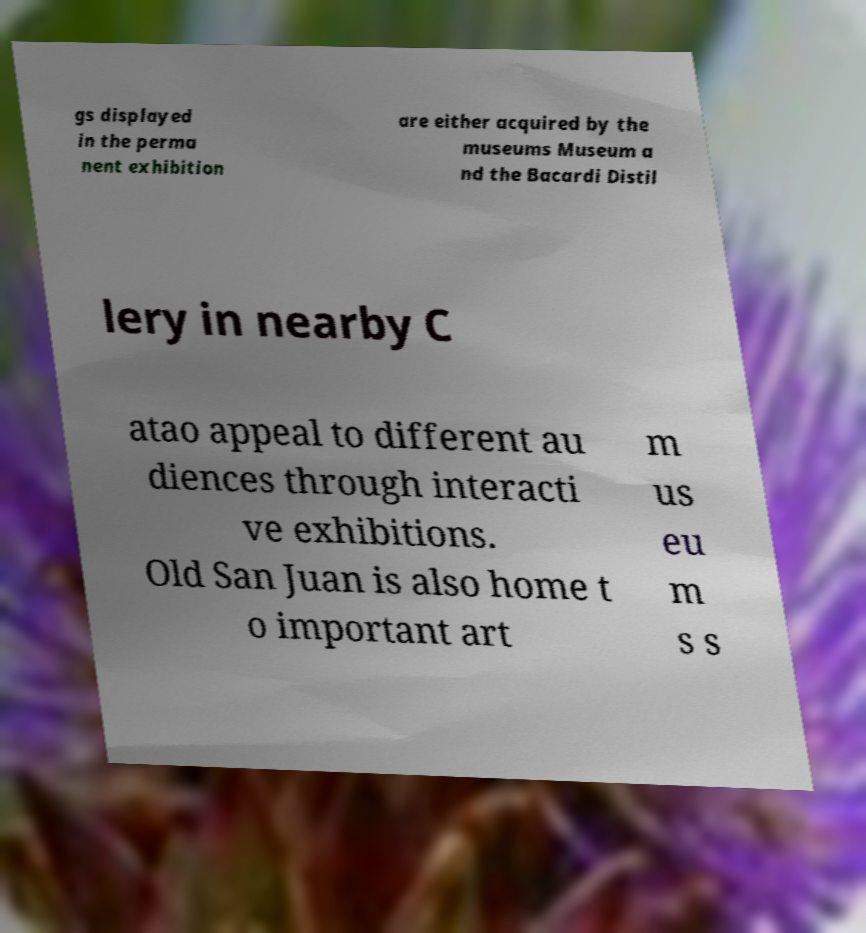For documentation purposes, I need the text within this image transcribed. Could you provide that? gs displayed in the perma nent exhibition are either acquired by the museums Museum a nd the Bacardi Distil lery in nearby C atao appeal to different au diences through interacti ve exhibitions. Old San Juan is also home t o important art m us eu m s s 